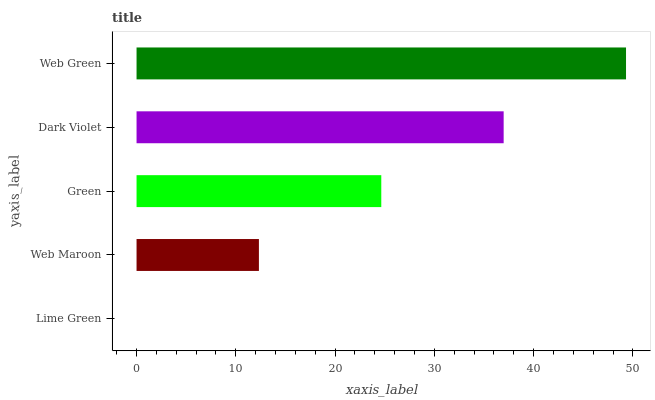Is Lime Green the minimum?
Answer yes or no. Yes. Is Web Green the maximum?
Answer yes or no. Yes. Is Web Maroon the minimum?
Answer yes or no. No. Is Web Maroon the maximum?
Answer yes or no. No. Is Web Maroon greater than Lime Green?
Answer yes or no. Yes. Is Lime Green less than Web Maroon?
Answer yes or no. Yes. Is Lime Green greater than Web Maroon?
Answer yes or no. No. Is Web Maroon less than Lime Green?
Answer yes or no. No. Is Green the high median?
Answer yes or no. Yes. Is Green the low median?
Answer yes or no. Yes. Is Lime Green the high median?
Answer yes or no. No. Is Dark Violet the low median?
Answer yes or no. No. 